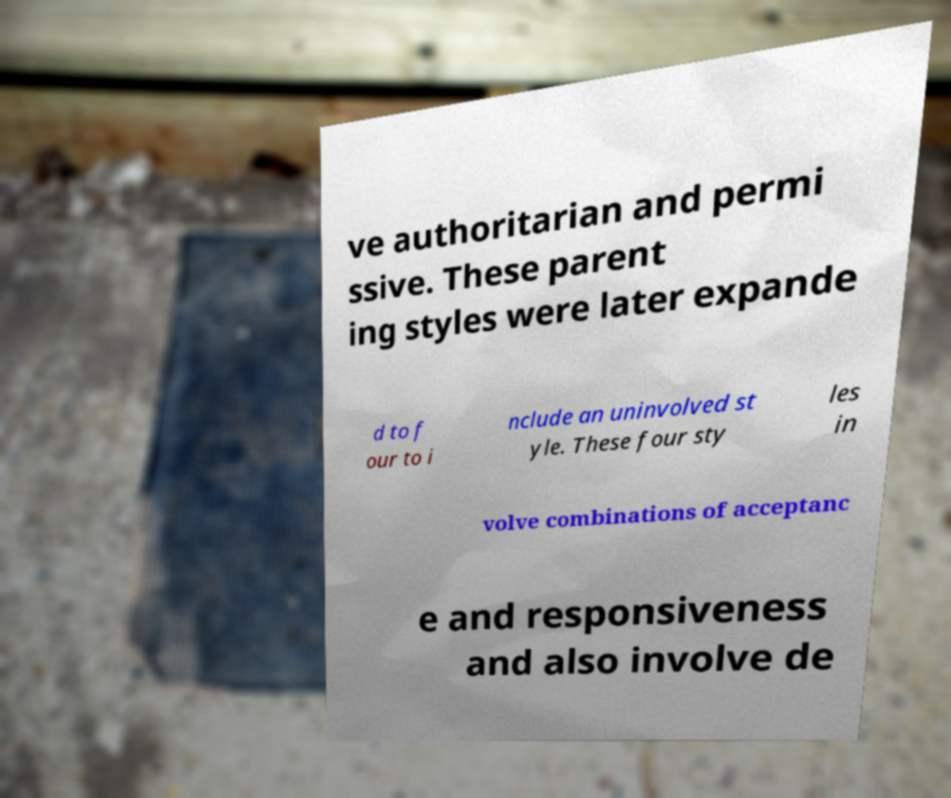Please read and relay the text visible in this image. What does it say? ve authoritarian and permi ssive. These parent ing styles were later expande d to f our to i nclude an uninvolved st yle. These four sty les in volve combinations of acceptanc e and responsiveness and also involve de 